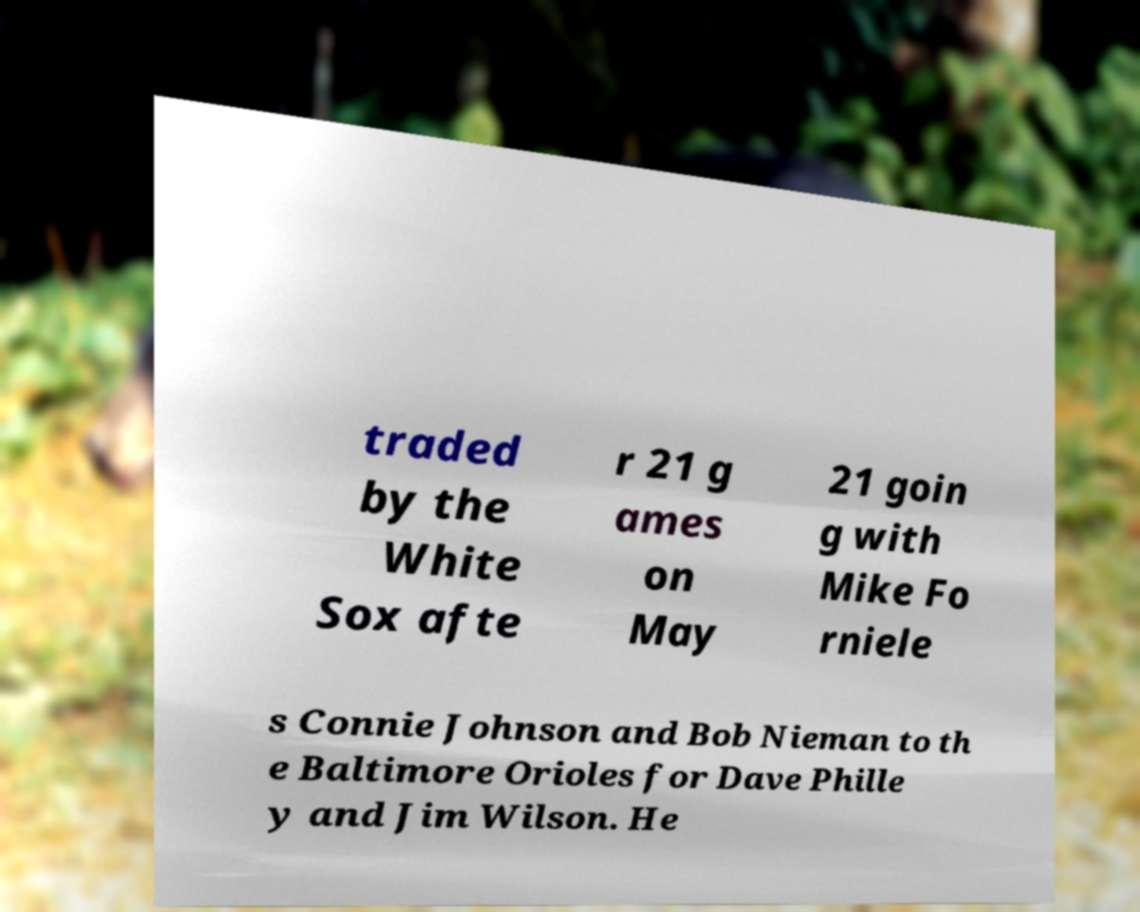Please identify and transcribe the text found in this image. traded by the White Sox afte r 21 g ames on May 21 goin g with Mike Fo rniele s Connie Johnson and Bob Nieman to th e Baltimore Orioles for Dave Phille y and Jim Wilson. He 